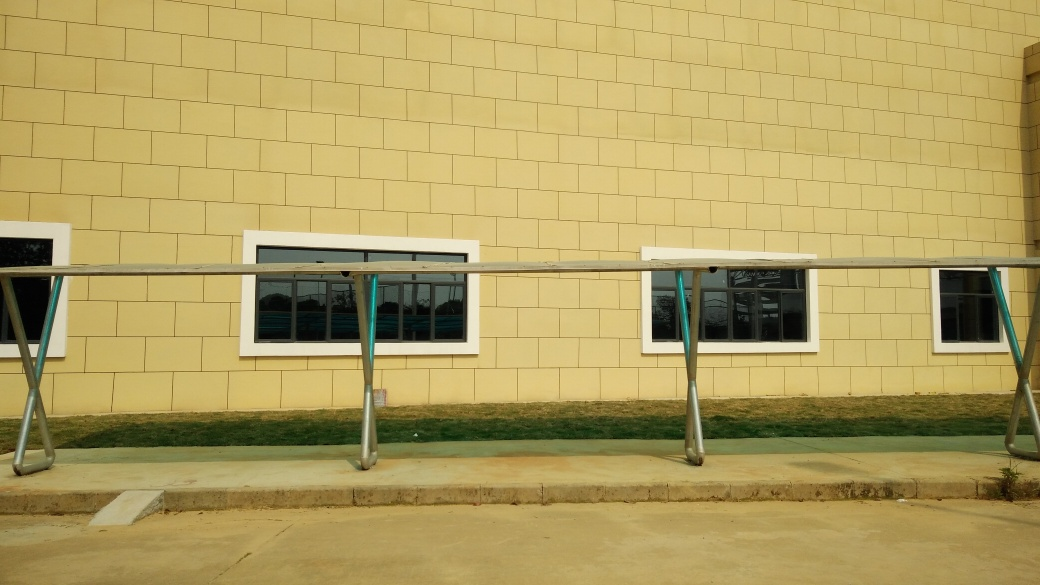Can you describe the architectural style or elements visible in this image? The architecture in the image showcases a modern utilitarian style. The building features a simple geometric design with clean lines and a minimalistic approach. The use of uniformly-sized, beige-colored tiles gives the facade a cohesive and orderly appearance. The presence of the metal railing in front adds an industrial touch to the setting. 